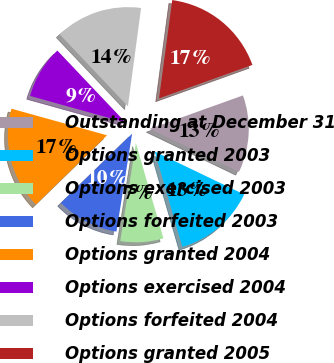Convert chart. <chart><loc_0><loc_0><loc_500><loc_500><pie_chart><fcel>Outstanding at December 31<fcel>Options granted 2003<fcel>Options exercised 2003<fcel>Options forfeited 2003<fcel>Options granted 2004<fcel>Options exercised 2004<fcel>Options forfeited 2004<fcel>Options granted 2005<nl><fcel>12.6%<fcel>13.4%<fcel>7.0%<fcel>10.2%<fcel>16.6%<fcel>8.6%<fcel>14.2%<fcel>17.4%<nl></chart> 